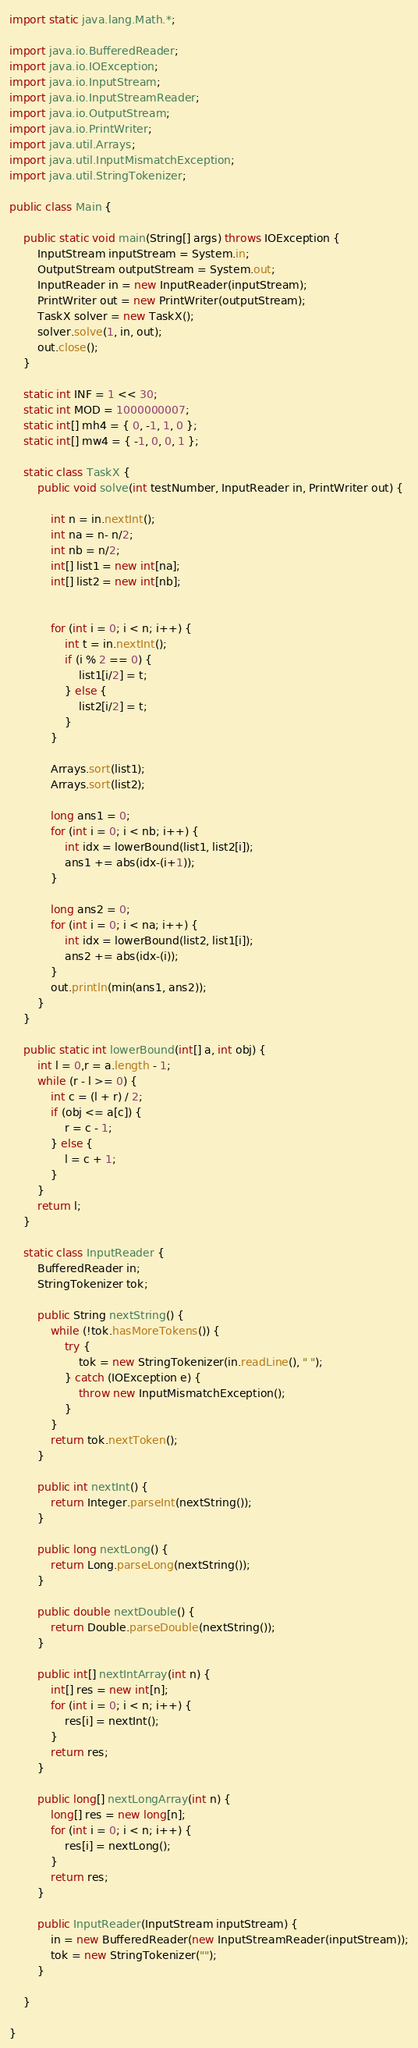Convert code to text. <code><loc_0><loc_0><loc_500><loc_500><_Java_>
import static java.lang.Math.*;

import java.io.BufferedReader;
import java.io.IOException;
import java.io.InputStream;
import java.io.InputStreamReader;
import java.io.OutputStream;
import java.io.PrintWriter;
import java.util.Arrays;
import java.util.InputMismatchException;
import java.util.StringTokenizer;

public class Main {

	public static void main(String[] args) throws IOException {
		InputStream inputStream = System.in;
		OutputStream outputStream = System.out;
		InputReader in = new InputReader(inputStream);
		PrintWriter out = new PrintWriter(outputStream);
		TaskX solver = new TaskX();
		solver.solve(1, in, out);
		out.close();
	}

	static int INF = 1 << 30;
	static int MOD = 1000000007;
	static int[] mh4 = { 0, -1, 1, 0 };
	static int[] mw4 = { -1, 0, 0, 1 };

	static class TaskX {
		public void solve(int testNumber, InputReader in, PrintWriter out) {

			int n = in.nextInt();
			int na = n- n/2;
			int nb = n/2;
			int[] list1 = new int[na];
			int[] list2 = new int[nb];


			for (int i = 0; i < n; i++) {
				int t = in.nextInt();
				if (i % 2 == 0) {
					list1[i/2] = t;
				} else {
					list2[i/2] = t;
				}
			}

			Arrays.sort(list1);
			Arrays.sort(list2);

			long ans1 = 0;
			for (int i = 0; i < nb; i++) {
				int idx = lowerBound(list1, list2[i]);
				ans1 += abs(idx-(i+1));
			}

			long ans2 = 0;
			for (int i = 0; i < na; i++) {
				int idx = lowerBound(list2, list1[i]);
				ans2 += abs(idx-(i));
			}
			out.println(min(ans1, ans2));
		}
	}

	public static int lowerBound(int[] a, int obj) {
		int l = 0,r = a.length - 1;
		while (r - l >= 0) {
			int c = (l + r) / 2;
			if (obj <= a[c]) {
				r = c - 1;
			} else {
				l = c + 1;
			}
		}
		return l;
	}

	static class InputReader {
		BufferedReader in;
		StringTokenizer tok;

		public String nextString() {
			while (!tok.hasMoreTokens()) {
				try {
					tok = new StringTokenizer(in.readLine(), " ");
				} catch (IOException e) {
					throw new InputMismatchException();
				}
			}
			return tok.nextToken();
		}

		public int nextInt() {
			return Integer.parseInt(nextString());
		}

		public long nextLong() {
			return Long.parseLong(nextString());
		}

		public double nextDouble() {
			return Double.parseDouble(nextString());
		}

		public int[] nextIntArray(int n) {
			int[] res = new int[n];
			for (int i = 0; i < n; i++) {
				res[i] = nextInt();
			}
			return res;
		}

		public long[] nextLongArray(int n) {
			long[] res = new long[n];
			for (int i = 0; i < n; i++) {
				res[i] = nextLong();
			}
			return res;
		}

		public InputReader(InputStream inputStream) {
			in = new BufferedReader(new InputStreamReader(inputStream));
			tok = new StringTokenizer("");
		}

	}

}
</code> 